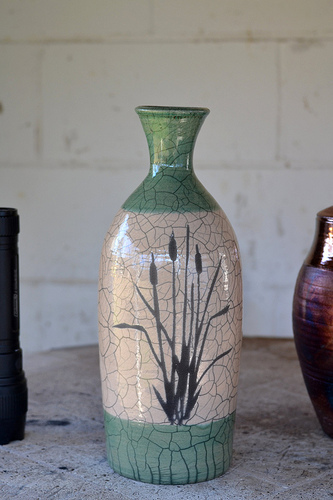<image>
Is the wall behind the pot? Yes. From this viewpoint, the wall is positioned behind the pot, with the pot partially or fully occluding the wall. 